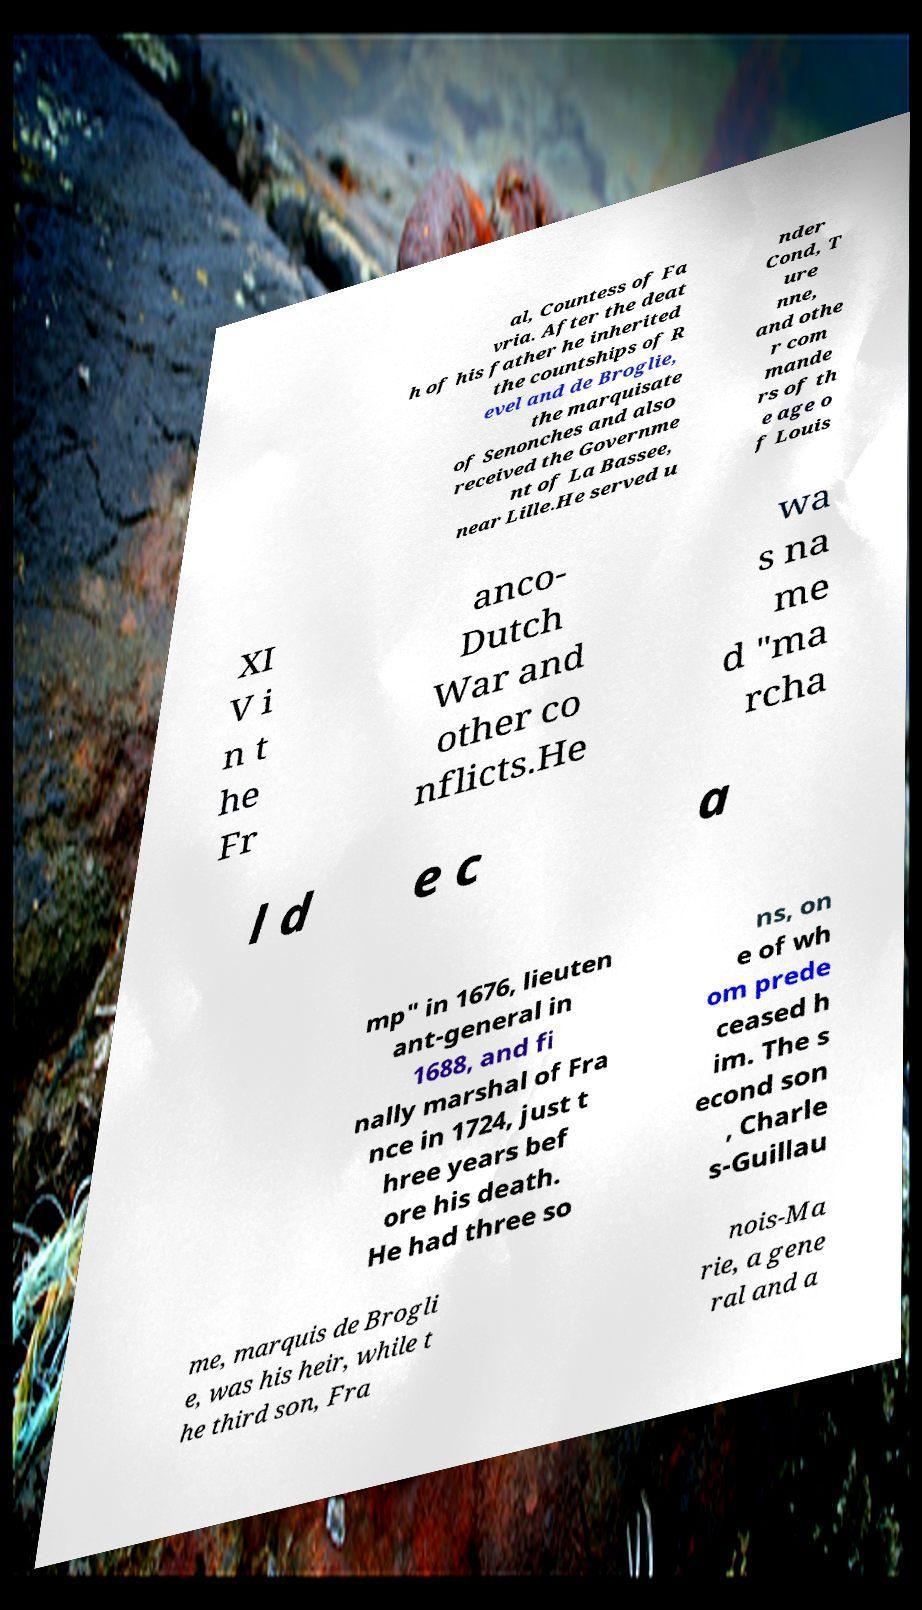Can you accurately transcribe the text from the provided image for me? al, Countess of Fa vria. After the deat h of his father he inherited the countships of R evel and de Broglie, the marquisate of Senonches and also received the Governme nt of La Bassee, near Lille.He served u nder Cond, T ure nne, and othe r com mande rs of th e age o f Louis XI V i n t he Fr anco- Dutch War and other co nflicts.He wa s na me d "ma rcha l d e c a mp" in 1676, lieuten ant-general in 1688, and fi nally marshal of Fra nce in 1724, just t hree years bef ore his death. He had three so ns, on e of wh om prede ceased h im. The s econd son , Charle s-Guillau me, marquis de Brogli e, was his heir, while t he third son, Fra nois-Ma rie, a gene ral and a 